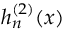<formula> <loc_0><loc_0><loc_500><loc_500>h _ { n } ^ { ( 2 ) } ( x )</formula> 